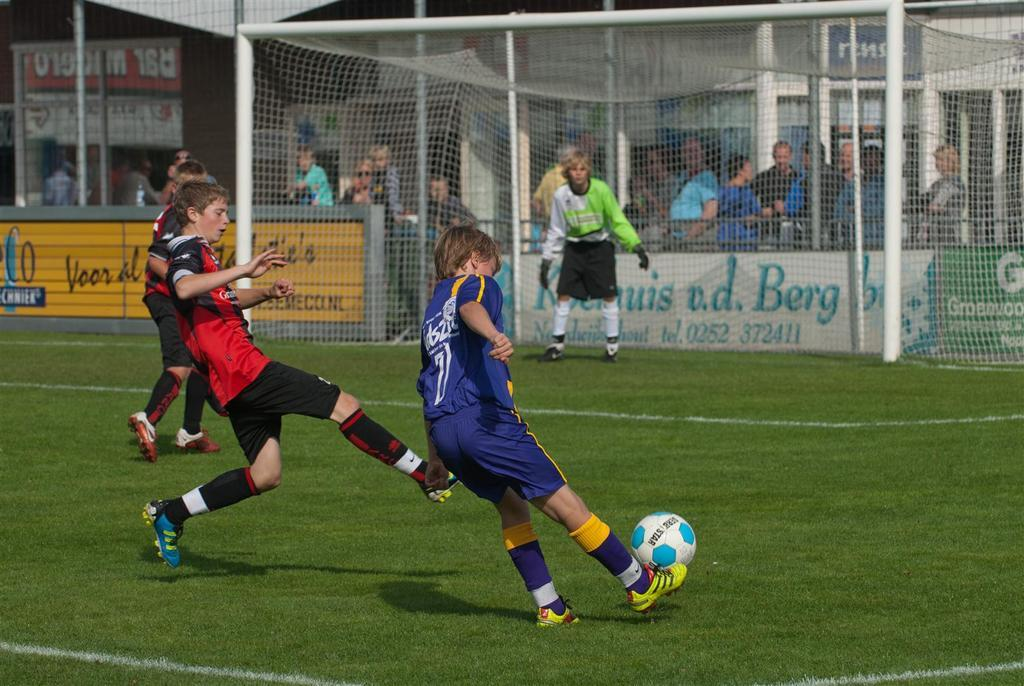<image>
Render a clear and concise summary of the photo. Player number 7 has the soccer ball and leans over to kick it. 